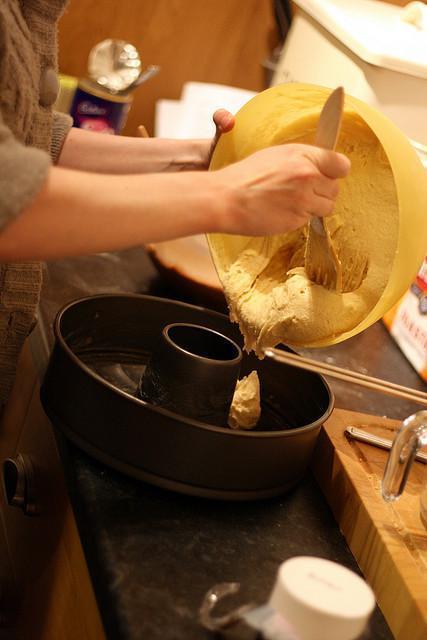What is being poured here?
Select the accurate answer and provide explanation: 'Answer: answer
Rationale: rationale.'
Options: Corn mush, grits, cake batter, milk. Answer: cake batter.
Rationale: The person is making is bundt cake. 